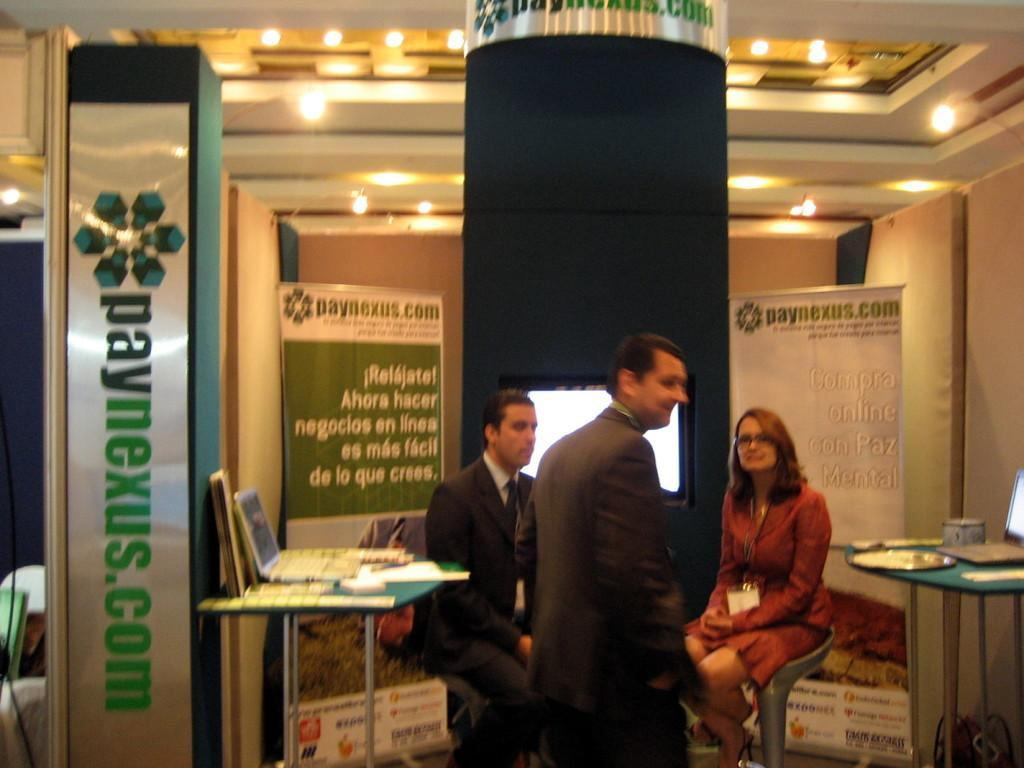What are the people in the image doing? The people in the image are sitting on chairs. Is there anyone standing in the image? Yes, there is a person standing in the image. What electronic device can be seen on a table in the image? There is a laptop on a table in the image. What type of decoration or signage is visible in the image? There are banners visible in the image. How many sisters are present in the image? There is no mention of sisters in the image, so we cannot determine the number of sisters present. 